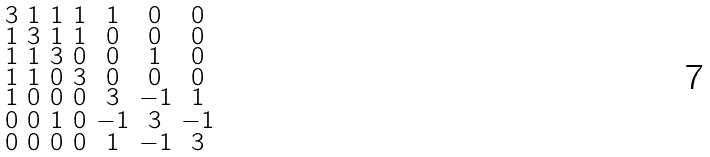Convert formula to latex. <formula><loc_0><loc_0><loc_500><loc_500>\begin{smallmatrix} 3 & 1 & 1 & 1 & 1 & 0 & 0 \\ 1 & 3 & 1 & 1 & 0 & 0 & 0 \\ 1 & 1 & 3 & 0 & 0 & 1 & 0 \\ 1 & 1 & 0 & 3 & 0 & 0 & 0 \\ 1 & 0 & 0 & 0 & 3 & - 1 & 1 \\ 0 & 0 & 1 & 0 & - 1 & 3 & - 1 \\ 0 & 0 & 0 & 0 & 1 & - 1 & 3 \end{smallmatrix}</formula> 